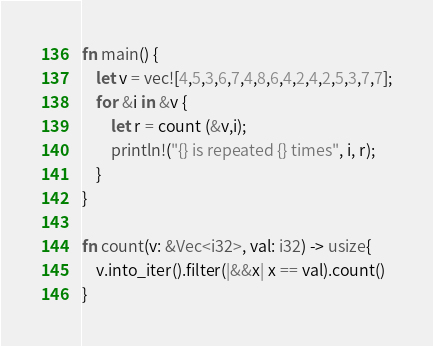Convert code to text. <code><loc_0><loc_0><loc_500><loc_500><_Rust_>fn main() {
    let v = vec![4,5,3,6,7,4,8,6,4,2,4,2,5,3,7,7];
    for &i in &v {
        let r = count (&v,i);
        println!("{} is repeated {} times", i, r);
    }
}

fn count(v: &Vec<i32>, val: i32) -> usize{
    v.into_iter().filter(|&&x| x == val).count()
}</code> 